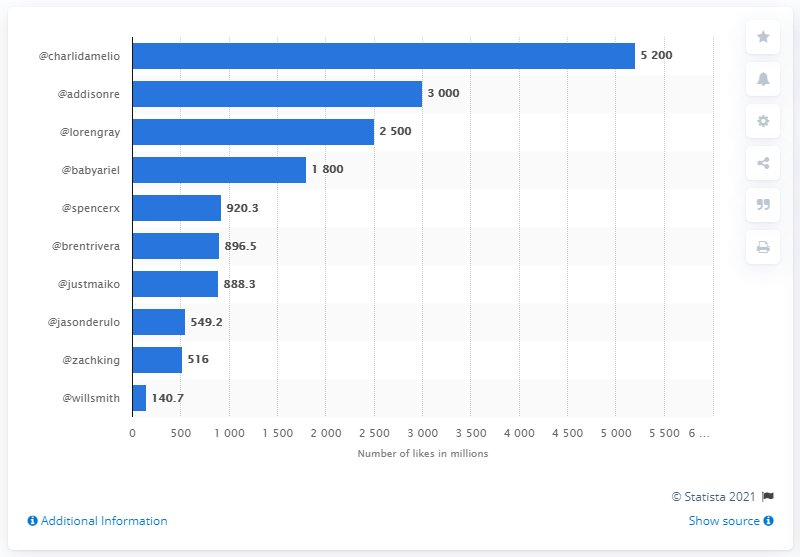Who is the second most liked content creator according to this chart? The second most liked content creator according to the chart is Addison Rae, with roughly 3000 million likes, or about 3 billion likes. 